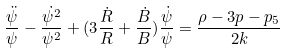Convert formula to latex. <formula><loc_0><loc_0><loc_500><loc_500>\frac { \ddot { \psi } } { \psi } - \frac { \dot { \psi ^ { 2 } } } { \psi ^ { 2 } } + ( 3 \frac { \dot { R } } { R } + \frac { \dot { B } } { B } ) \frac { \dot { \psi } } { \psi } = \frac { \rho - 3 p - p _ { 5 } } { 2 k }</formula> 